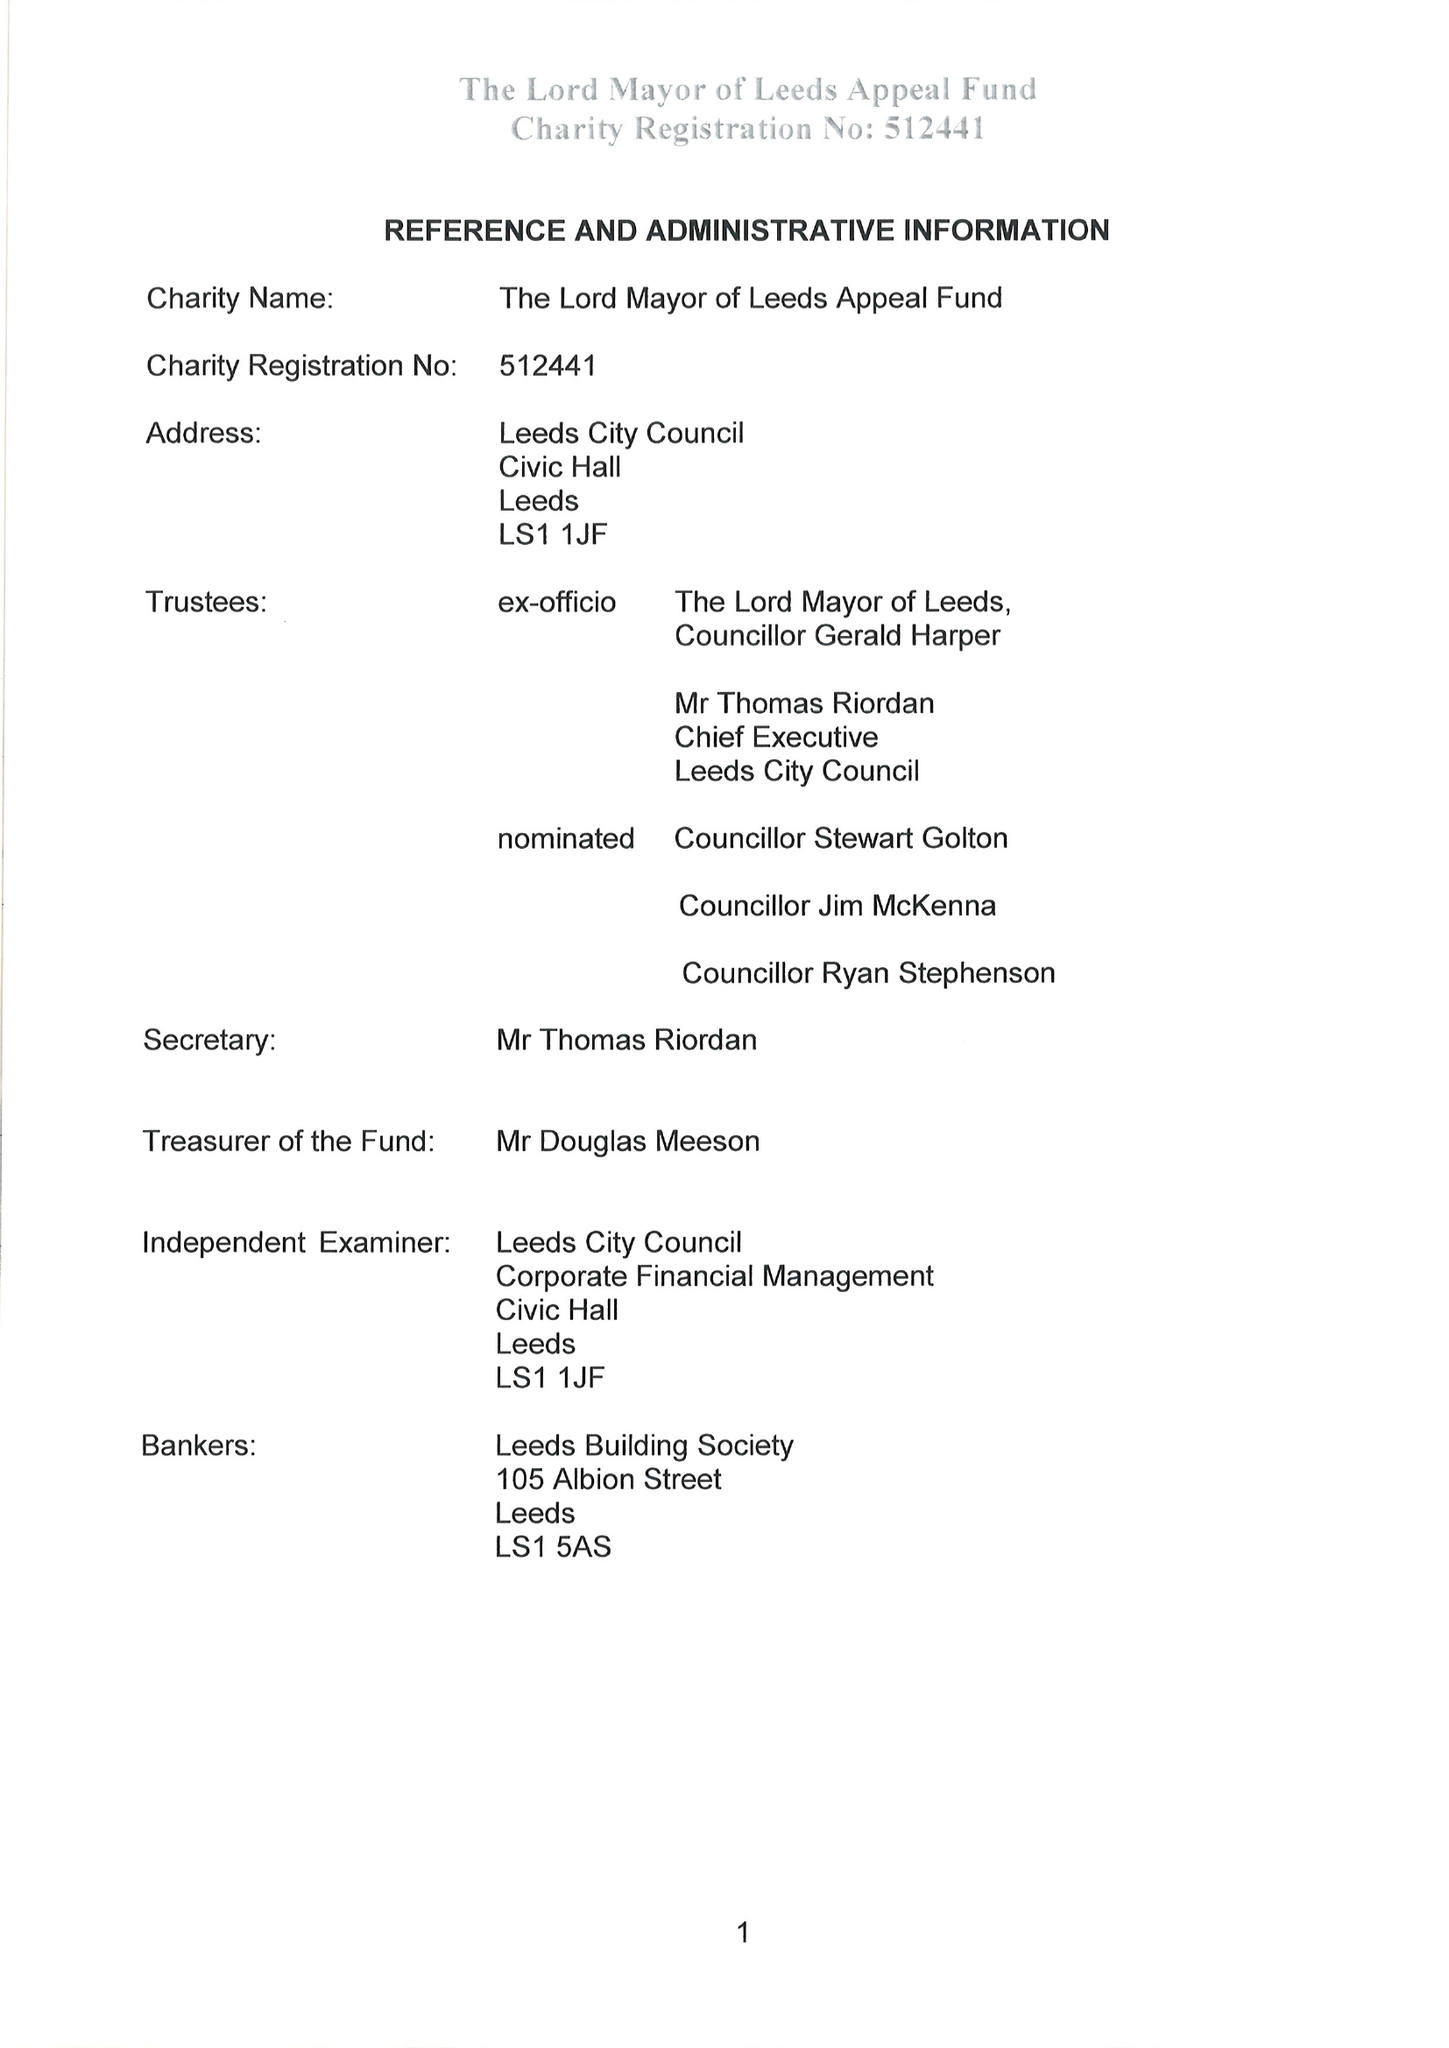What is the value for the report_date?
Answer the question using a single word or phrase. 2017-05-31 